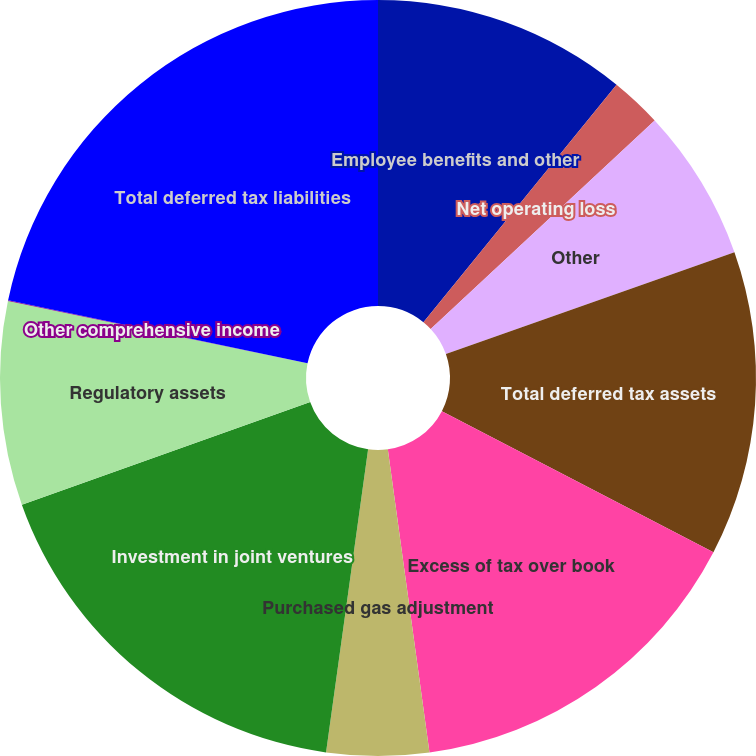Convert chart. <chart><loc_0><loc_0><loc_500><loc_500><pie_chart><fcel>Employee benefits and other<fcel>Net operating loss<fcel>Other<fcel>Total deferred tax assets<fcel>Excess of tax over book<fcel>Purchased gas adjustment<fcel>Investment in joint ventures<fcel>Regulatory assets<fcel>Other comprehensive income<fcel>Total deferred tax liabilities<nl><fcel>10.87%<fcel>2.2%<fcel>6.53%<fcel>13.03%<fcel>15.2%<fcel>4.37%<fcel>17.37%<fcel>8.7%<fcel>0.04%<fcel>21.7%<nl></chart> 